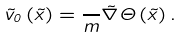Convert formula to latex. <formula><loc_0><loc_0><loc_500><loc_500>\vec { v } _ { 0 } \left ( \vec { x } \right ) = \frac { } { m } \vec { \nabla } \Theta \left ( \vec { x } \right ) .</formula> 